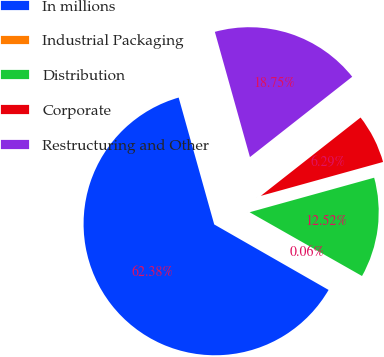Convert chart. <chart><loc_0><loc_0><loc_500><loc_500><pie_chart><fcel>In millions<fcel>Industrial Packaging<fcel>Distribution<fcel>Corporate<fcel>Restructuring and Other<nl><fcel>62.37%<fcel>0.06%<fcel>12.52%<fcel>6.29%<fcel>18.75%<nl></chart> 